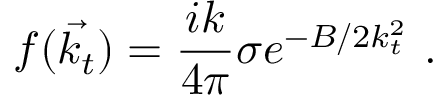<formula> <loc_0><loc_0><loc_500><loc_500>f ( \vec { k _ { t } } ) = \frac { i k } { 4 \pi } \sigma e ^ { - B / 2 k _ { t } ^ { 2 } } \ .</formula> 